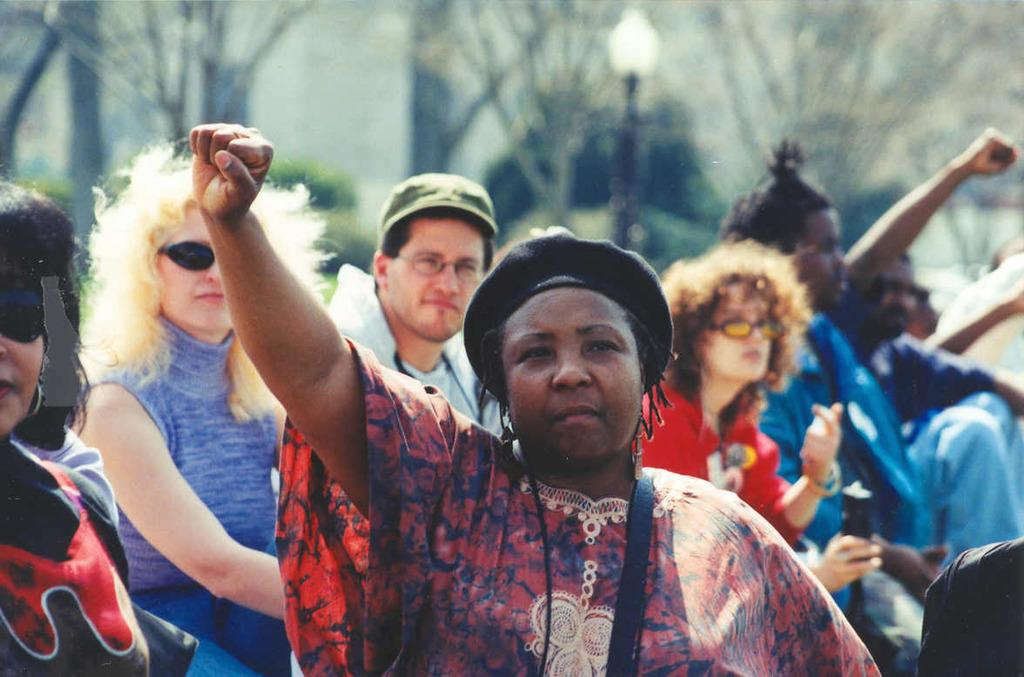What is the main subject of the image? There is a group of people in the image. Can you describe the lighting in the image? There is light in the image. How would you describe the background of the image? The background of the image is blurry. What type of plant is growing in the mist in the image? There is no mist or plant present in the image. 